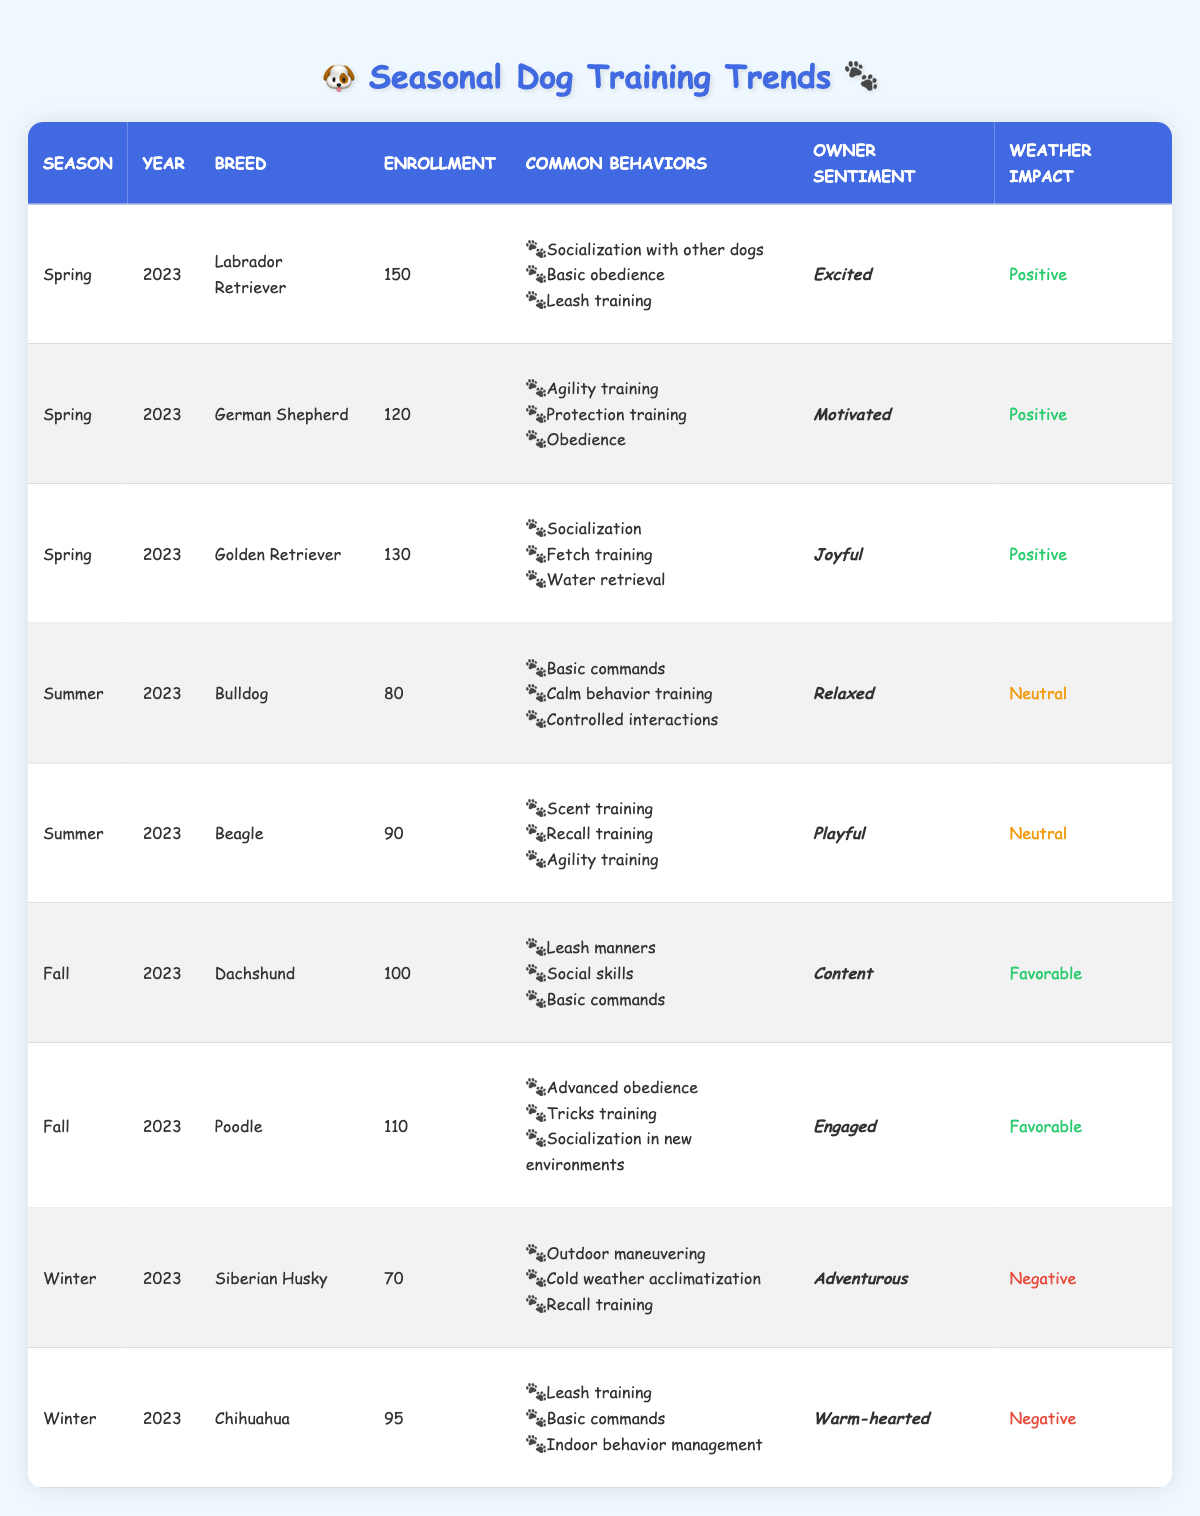What is the total enrollment for dog training in Spring 2023? To find the total enrollment for Spring 2023, we sum the enrollment numbers of all breeds in that season: 150 (Labrador Retriever) + 120 (German Shepherd) + 130 (Golden Retriever) = 400.
Answer: 400 Which breed had the highest enrollment in Summer 2023? Looking at the Summer 2023 data, Bulldog has an enrollment of 80 and Beagle has 90. Since 90 is greater than 80, Beagle had the highest enrollment.
Answer: Beagle Did any breed have a negative weather impact during Winter 2023? The table lists the weather impact for Siberian Husky and Chihuahua during Winter 2023 as negative. Therefore, yes, both breeds had a negative weather impact.
Answer: Yes What percentage of the total enrollment in Fall 2023 does Poodle's enrollment represent? The total enrollment for Fall 2023 is 100 (Dachshund) + 110 (Poodle) = 210. Poodle’s enrollment is 110, which is (110/210) * 100 = 52.38%.
Answer: 52.38% How many breeds had an owner's sentiment described as joyful? Only the Golden Retriever has an owner sentiment categorized as joyful according to the table.
Answer: 1 What is the average enrollment for dog training across all seasons and breeds listed in the table? The total enrollment is 150 + 120 + 130 + 80 + 90 + 100 + 110 + 70 + 95 = 1,045. There are 9 entries (breeds). The average enrollment is 1,045 / 9 = 116.11.
Answer: 116.11 Which season had the most breeds with positive owner sentiment? In Spring 2023, all breeds (Labrador Retriever, German Shepherd, Golden Retriever) had positive sentiment. In Fall 2023, both breeds also had favorable sentiment. Therefore, Spring has more positive sentiments.
Answer: Spring What common behavior was most prevalent among the breeds in Spring 2023? The data shows three behaviors for each breed in Spring, with common phrases like socialization appearing in Labrador, Golden Retriever, and similar obedience traits. However, "Socialization" appears across two breeds.
Answer: Socialization Are there any breeds with neutral weather impact that also received a high enrollment? In Summer 2023, both Bulldog and Beagle had a neutral weather impact. Beagle had an enrollment of 90, which is relatively high compared to Bulldog's 80. Hence, yes, Beagle fits this category.
Answer: Yes What was the highest owner sentiment among all breeds trained in Winter 2023? The owner sentiments for Siberian Husky is adventurous and for Chihuahua is warm-hearted. Adventurous ranks as a more positive sentiment when compared to warm-hearted. Hence, adventurous is the highest sentiment.
Answer: Adventurous 